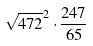Convert formula to latex. <formula><loc_0><loc_0><loc_500><loc_500>\sqrt { 4 7 2 } ^ { 2 } \cdot \frac { 2 4 7 } { 6 5 }</formula> 